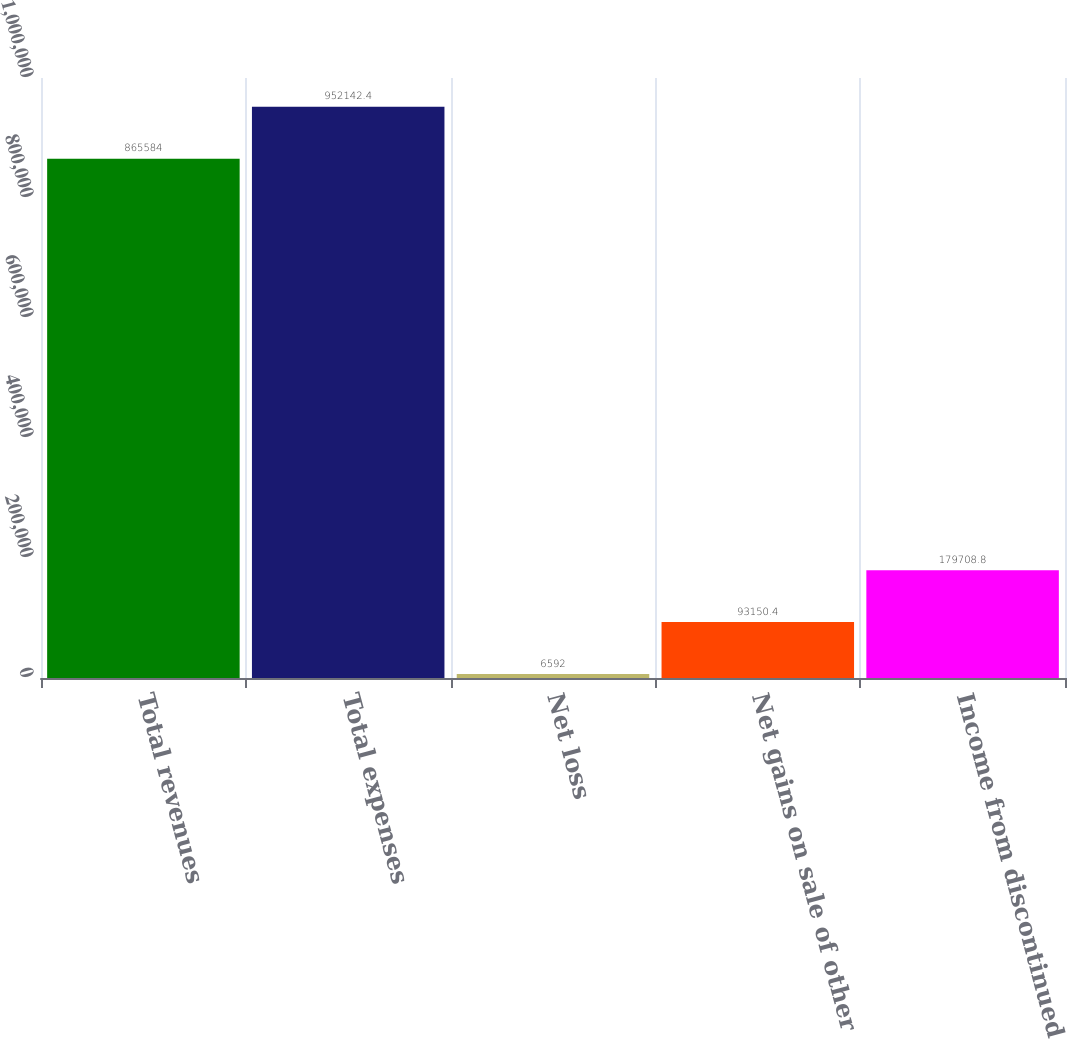Convert chart to OTSL. <chart><loc_0><loc_0><loc_500><loc_500><bar_chart><fcel>Total revenues<fcel>Total expenses<fcel>Net loss<fcel>Net gains on sale of other<fcel>Income from discontinued<nl><fcel>865584<fcel>952142<fcel>6592<fcel>93150.4<fcel>179709<nl></chart> 